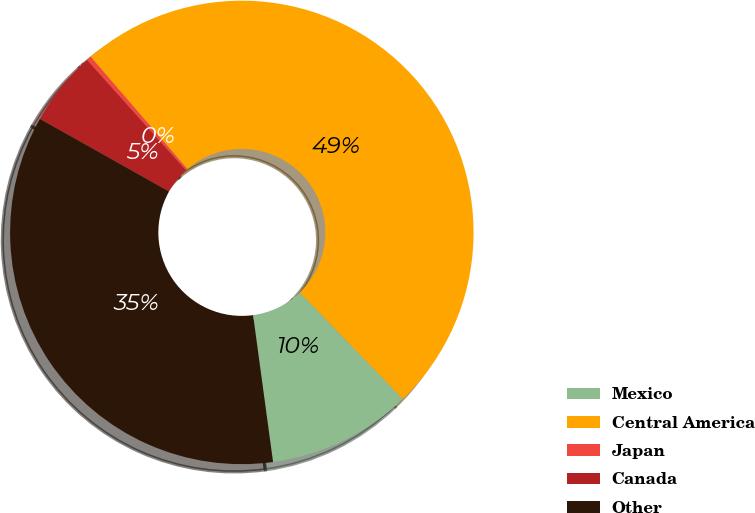<chart> <loc_0><loc_0><loc_500><loc_500><pie_chart><fcel>Mexico<fcel>Central America<fcel>Japan<fcel>Canada<fcel>Other<nl><fcel>10.08%<fcel>49.08%<fcel>0.33%<fcel>5.21%<fcel>35.3%<nl></chart> 